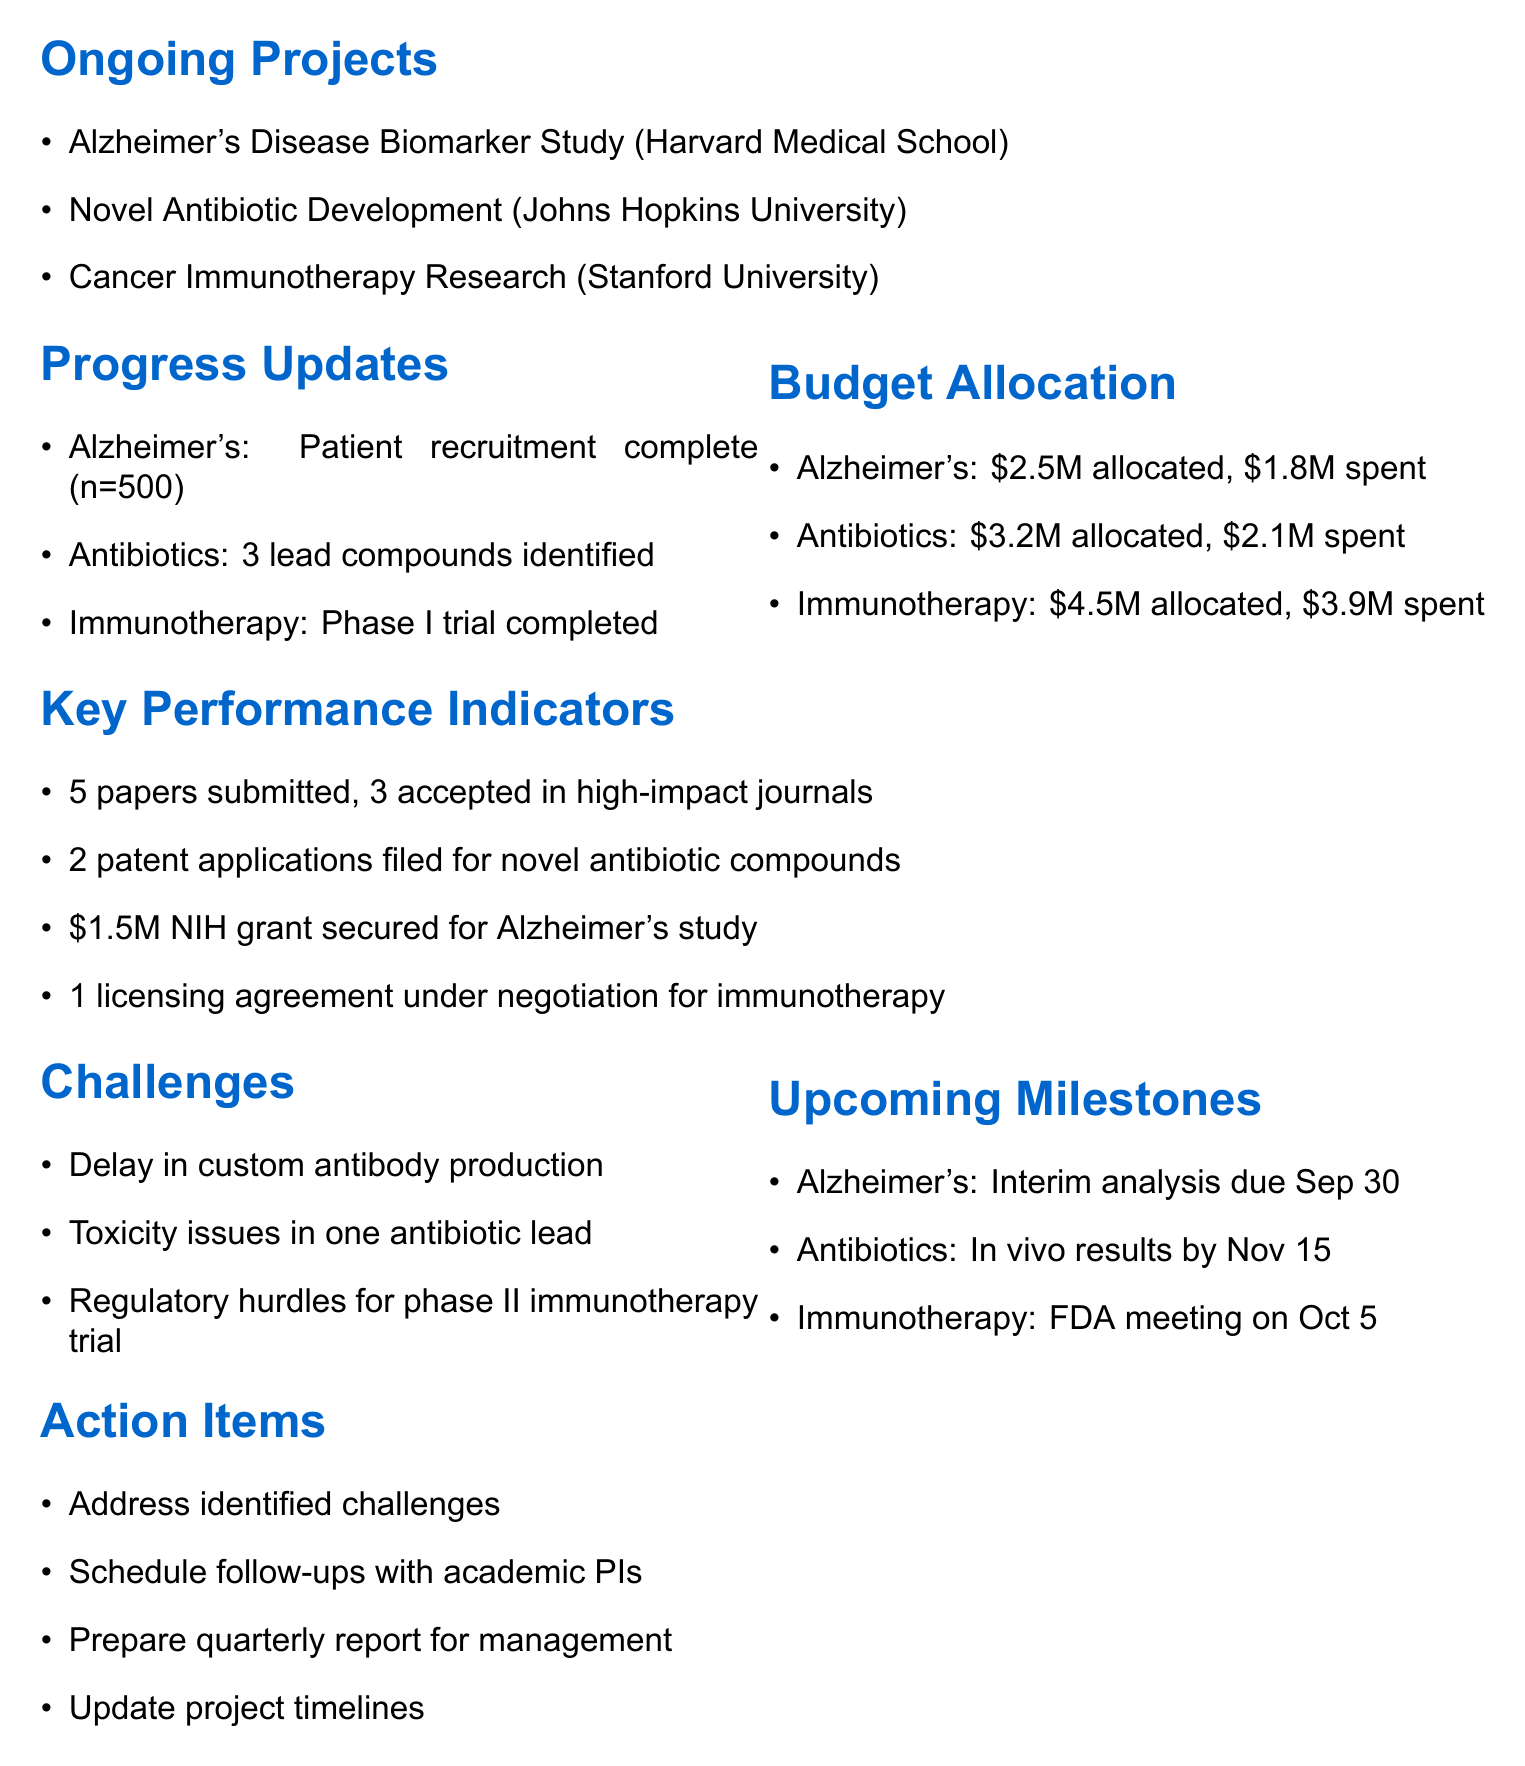What is the total budget allocated for the Alzheimer's Study? The document states that $2.5M is allocated for the Alzheimer's Study.
Answer: $2.5M How many lead compounds were identified in the Antibiotic Development project? The document mentions that 3 lead compounds were identified in the Antibiotic Development project.
Answer: 3 What is the status of the Immunotherapy Research project as of now? The document states that the phase I clinical trial is completed, and data analysis is underway for publication.
Answer: Phase I trial completed What was the amount spent to date for the Immunotherapy Research project? The document indicates that $3.9M has been spent to date on the Immunotherapy Research project.
Answer: $3.9M What is the expected timeline for the interim data analysis of the Alzheimer's Study? The document specifies that the interim data analysis is due by September 30.
Answer: September 30 What challenge is affecting the Alzheimer's Study? The document outlines a delay in custom antibody production as a challenge for the Alzheimer's Study.
Answer: Delay in custom antibody production How many papers were accepted in high-impact journals? The document notes that 3 papers have been accepted in high-impact journals.
Answer: 3 What upcoming milestone is scheduled for October 5? According to the document, an FDA meeting is scheduled for October 5 to discuss phase II trial design.
Answer: FDA meeting What amount of grant funding was secured for the Alzheimer's study? The document states that a $1.5M NIH grant has been secured for the Alzheimer's study.
Answer: $1.5M What is one of the collaboration enhancement initiatives mentioned? The document lists a planned joint symposium with academic partners in Q4 as an initiative.
Answer: Planned joint symposium 